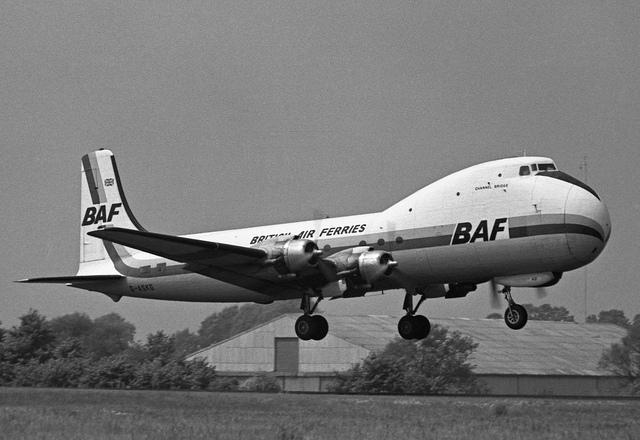Is the plane in the air?
Be succinct. Yes. Does the tail of the plane have stripes?
Keep it brief. Yes. How many tires are there?
Answer briefly. 5. Is the plane landing?
Keep it brief. Yes. What color is the stripe on the plane?
Short answer required. Black. Is it cloudy?
Be succinct. No. What letters are on the tail of the plane?
Short answer required. Baf. What is the name of the airline?
Short answer required. Baf. What's on the ground?
Write a very short answer. Grass. 